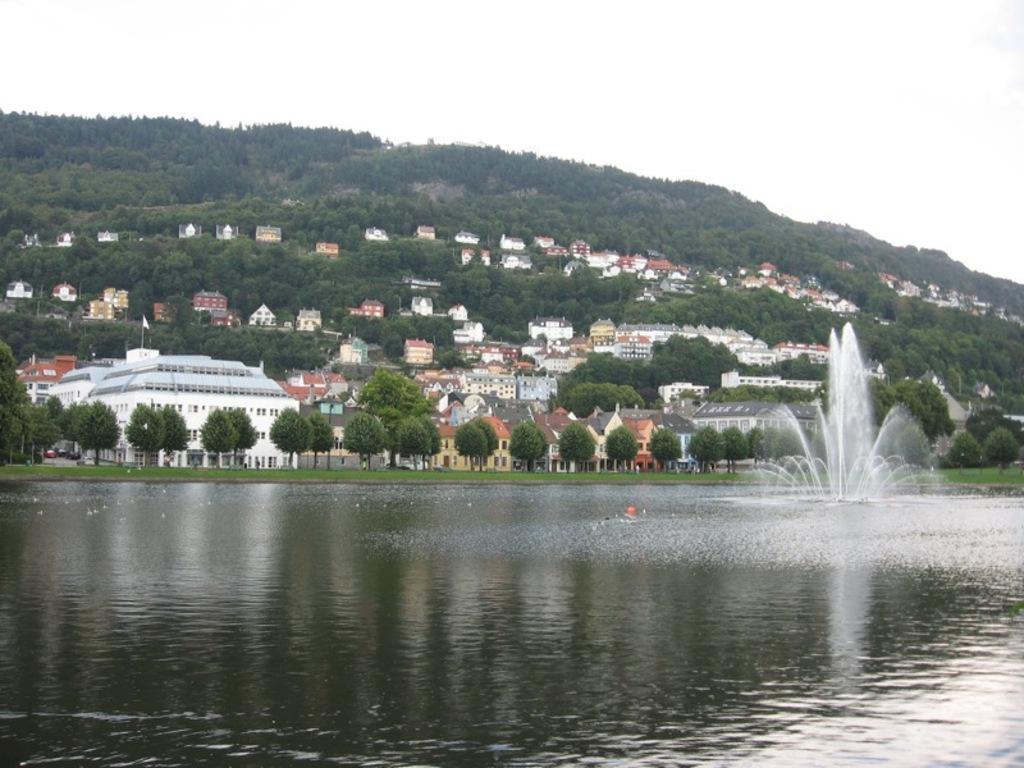Please provide a concise description of this image. In the picture there is a water surface and there is a fountain in between the water surface, behind that there are many trees and in between the trees there are some houses and buildings. 